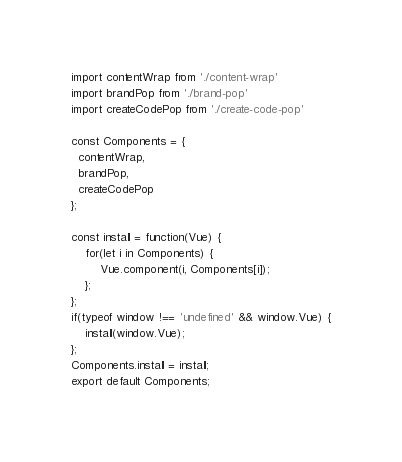<code> <loc_0><loc_0><loc_500><loc_500><_JavaScript_>
import contentWrap from './content-wrap'
import brandPop from './brand-pop'
import createCodePop from './create-code-pop'

const Components = {
  contentWrap,
  brandPop,
  createCodePop
};

const install = function(Vue) {
    for(let i in Components) {
        Vue.component(i, Components[i]);
    };
};
if(typeof window !== 'undefined' && window.Vue) {
    install(window.Vue);
};
Components.install = install;
export default Components;
</code> 